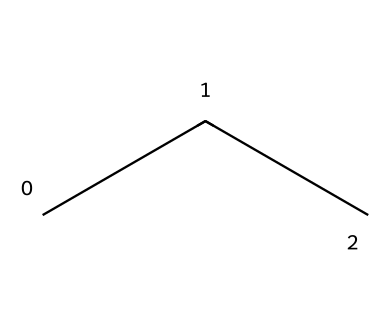What is the molecular formula for this refrigerant? The chemical structure is represented by the SMILES notation "CCC," which corresponds to a hydrocarbon with three carbon atoms and eight hydrogen atoms, giving us the formula C3H8.
Answer: C3H8 How many carbon atoms are in propane? From the SMILES "CCC," we can observe that there are three occurrences of the letter 'C,' indicating three carbon atoms in the structure.
Answer: 3 What is the primary type of bonds present in propane? In a hydrocarbon like propane, the bonds between carbon and hydrogen are single covalent bonds. This is evidenced by the structure containing only single bonds among the carbon and hydrogen atoms.
Answer: single Does propane contain any double or triple bonds? The SMILES representation "CCC" indicates that there are only single bonds, and there is no indication of double or triple bonds anywhere in the structure.
Answer: no What type of compound is propane classified as? Propane, indicated by the SMILES "CCC," is classified as an alkane, which is a type of hydrocarbon characterized by single bonds between carbon atoms.
Answer: alkane How does propane's structure contribute to its low environmental impact? The linear arrangement of propane in this structure allows it to be more stable and less reactive, which contributes to its use as a refrigerant with lower environmental impact compared to halogenated refrigerants, minimizing ozone depletion.
Answer: stability What is the general behavior of propane as a refrigerant? The structure of propane allows it to have good thermodynamic properties, making it an efficient refrigerant that can absorb and reject heat effectively during phase changes, which is essential for cooling processes.
Answer: efficient 